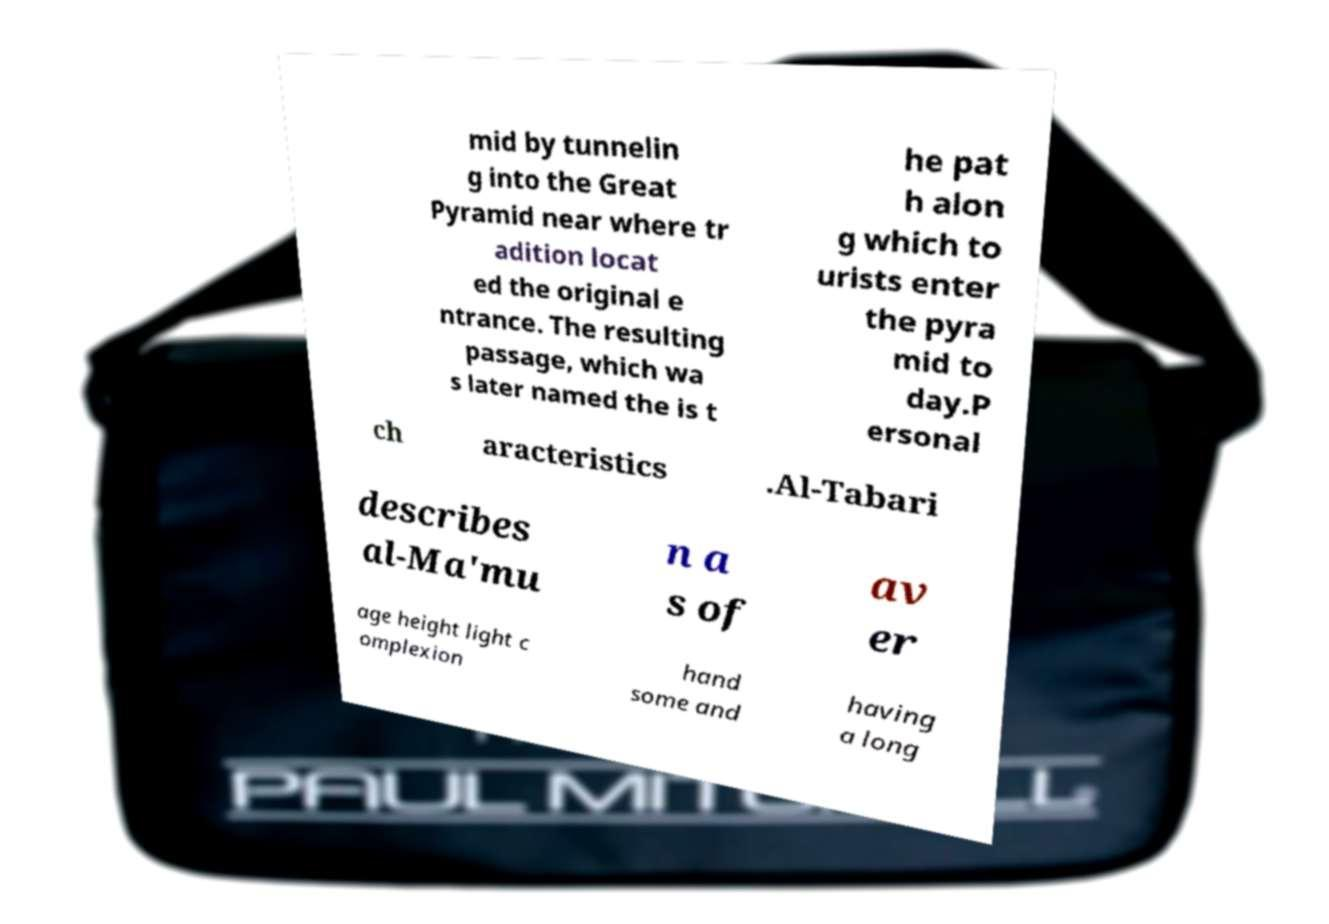Can you read and provide the text displayed in the image?This photo seems to have some interesting text. Can you extract and type it out for me? mid by tunnelin g into the Great Pyramid near where tr adition locat ed the original e ntrance. The resulting passage, which wa s later named the is t he pat h alon g which to urists enter the pyra mid to day.P ersonal ch aracteristics .Al-Tabari describes al-Ma'mu n a s of av er age height light c omplexion hand some and having a long 